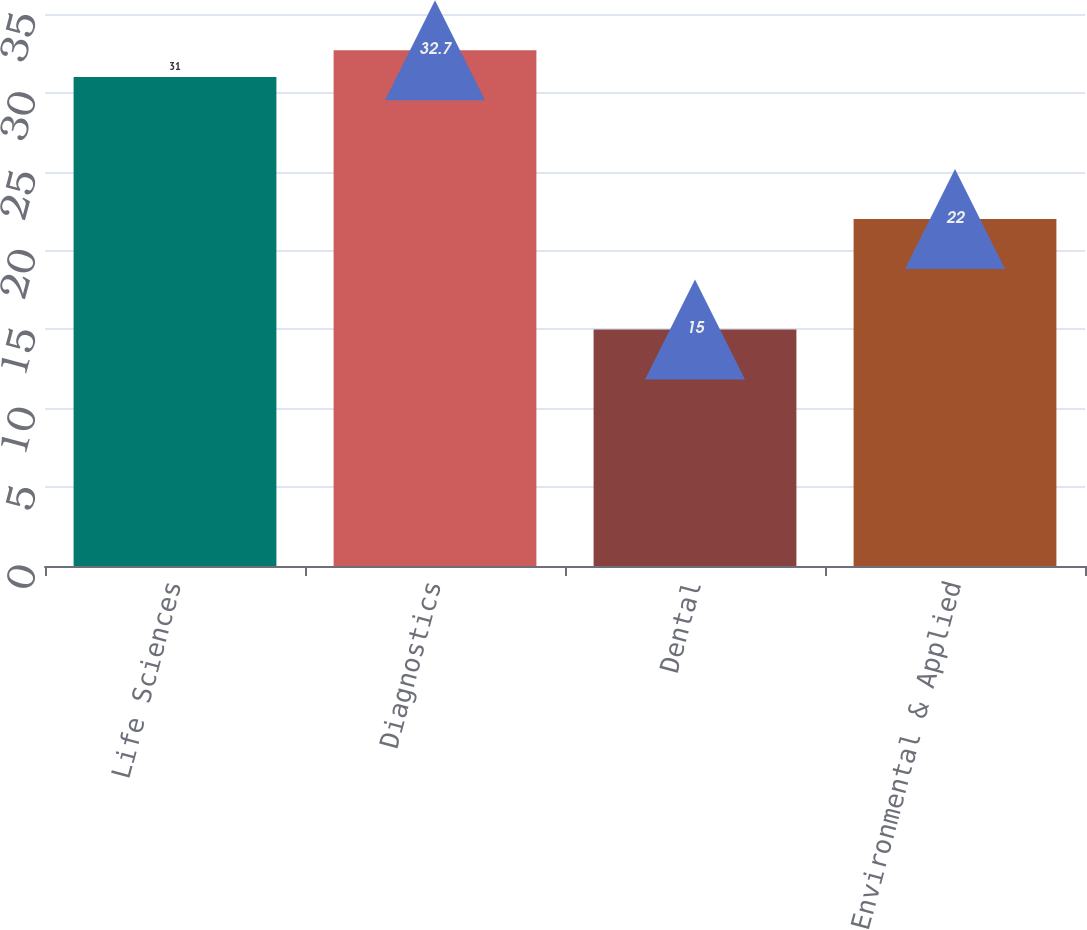Convert chart to OTSL. <chart><loc_0><loc_0><loc_500><loc_500><bar_chart><fcel>Life Sciences<fcel>Diagnostics<fcel>Dental<fcel>Environmental & Applied<nl><fcel>31<fcel>32.7<fcel>15<fcel>22<nl></chart> 